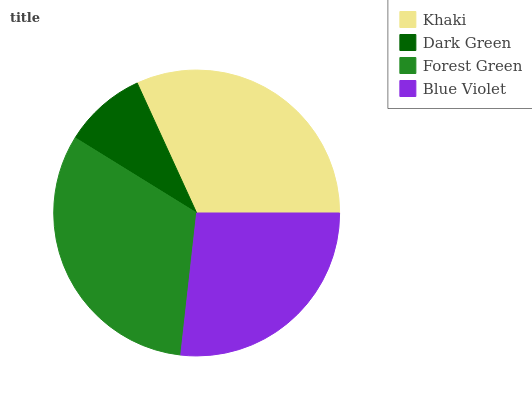Is Dark Green the minimum?
Answer yes or no. Yes. Is Forest Green the maximum?
Answer yes or no. Yes. Is Forest Green the minimum?
Answer yes or no. No. Is Dark Green the maximum?
Answer yes or no. No. Is Forest Green greater than Dark Green?
Answer yes or no. Yes. Is Dark Green less than Forest Green?
Answer yes or no. Yes. Is Dark Green greater than Forest Green?
Answer yes or no. No. Is Forest Green less than Dark Green?
Answer yes or no. No. Is Khaki the high median?
Answer yes or no. Yes. Is Blue Violet the low median?
Answer yes or no. Yes. Is Blue Violet the high median?
Answer yes or no. No. Is Forest Green the low median?
Answer yes or no. No. 